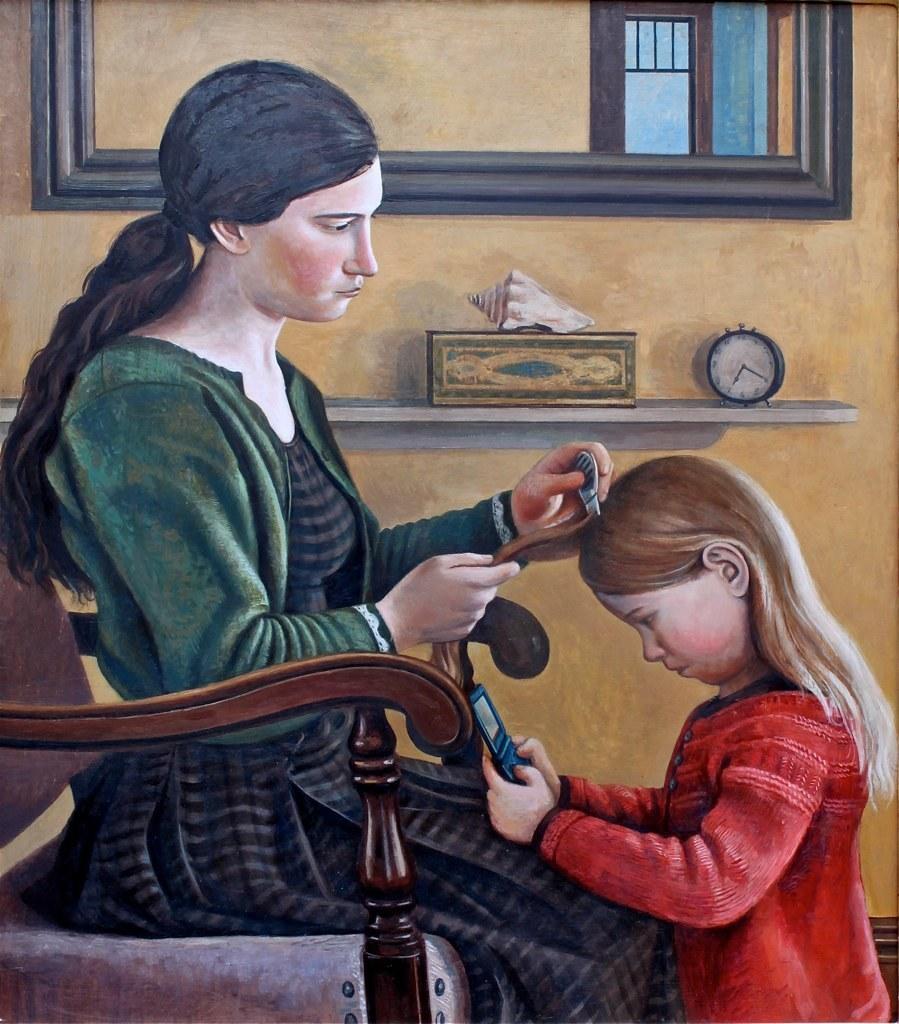How would you summarize this image in a sentence or two? It is a painting. In the center of the image we can see one woman sitting on the chair and she is holding a comb and hair. In front of her, we can see one girl holding a phone. And we can see they are wearing jackets, which are in green and red color. In the background there is a wall, window, wall shelf etc. On the wall shelf, we can see one alarm clock, box, shell and a few other objects. 